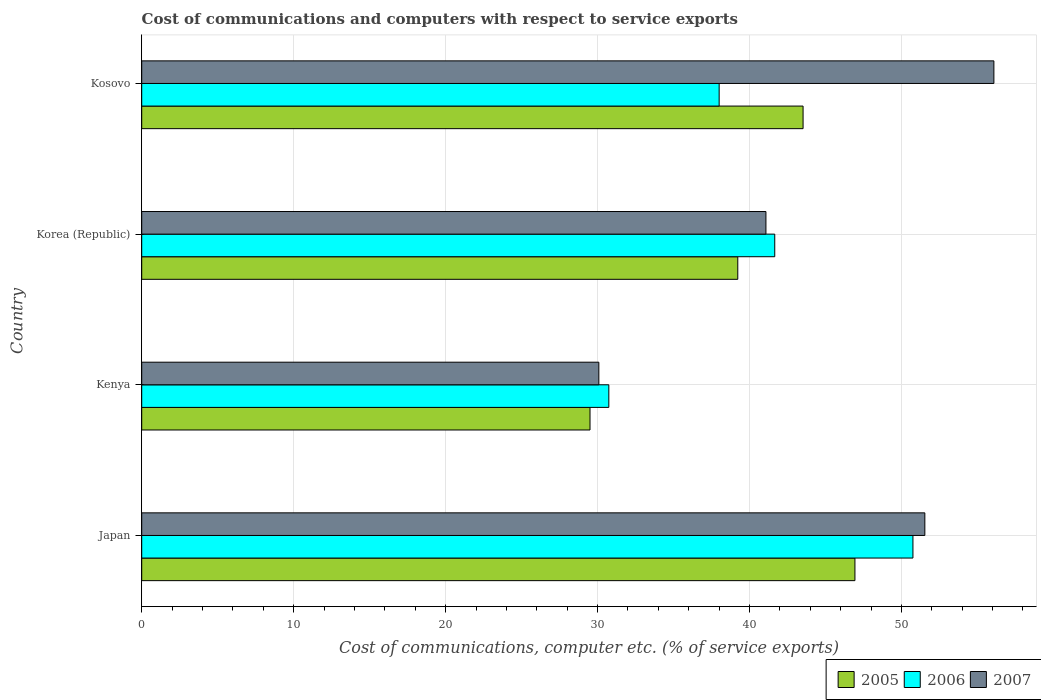How many different coloured bars are there?
Your response must be concise. 3. Are the number of bars per tick equal to the number of legend labels?
Provide a short and direct response. Yes. How many bars are there on the 2nd tick from the bottom?
Make the answer very short. 3. What is the label of the 2nd group of bars from the top?
Your answer should be very brief. Korea (Republic). In how many cases, is the number of bars for a given country not equal to the number of legend labels?
Provide a succinct answer. 0. What is the cost of communications and computers in 2005 in Japan?
Your answer should be compact. 46.94. Across all countries, what is the maximum cost of communications and computers in 2006?
Provide a short and direct response. 50.76. Across all countries, what is the minimum cost of communications and computers in 2005?
Offer a very short reply. 29.5. In which country was the cost of communications and computers in 2007 minimum?
Provide a succinct answer. Kenya. What is the total cost of communications and computers in 2007 in the graph?
Your answer should be very brief. 178.8. What is the difference between the cost of communications and computers in 2007 in Japan and that in Kenya?
Give a very brief answer. 21.46. What is the difference between the cost of communications and computers in 2007 in Kosovo and the cost of communications and computers in 2005 in Kenya?
Keep it short and to the point. 26.58. What is the average cost of communications and computers in 2006 per country?
Make the answer very short. 40.29. What is the difference between the cost of communications and computers in 2006 and cost of communications and computers in 2007 in Korea (Republic)?
Give a very brief answer. 0.58. What is the ratio of the cost of communications and computers in 2005 in Korea (Republic) to that in Kosovo?
Ensure brevity in your answer.  0.9. Is the cost of communications and computers in 2007 in Japan less than that in Kenya?
Make the answer very short. No. Is the difference between the cost of communications and computers in 2006 in Kenya and Korea (Republic) greater than the difference between the cost of communications and computers in 2007 in Kenya and Korea (Republic)?
Offer a terse response. Yes. What is the difference between the highest and the second highest cost of communications and computers in 2007?
Give a very brief answer. 4.54. What is the difference between the highest and the lowest cost of communications and computers in 2007?
Ensure brevity in your answer.  26. What does the 3rd bar from the top in Korea (Republic) represents?
Offer a very short reply. 2005. What does the 1st bar from the bottom in Kosovo represents?
Keep it short and to the point. 2005. Is it the case that in every country, the sum of the cost of communications and computers in 2005 and cost of communications and computers in 2006 is greater than the cost of communications and computers in 2007?
Your answer should be very brief. Yes. How many bars are there?
Provide a short and direct response. 12. Are all the bars in the graph horizontal?
Provide a short and direct response. Yes. What is the difference between two consecutive major ticks on the X-axis?
Give a very brief answer. 10. Are the values on the major ticks of X-axis written in scientific E-notation?
Keep it short and to the point. No. Does the graph contain any zero values?
Offer a terse response. No. Where does the legend appear in the graph?
Provide a short and direct response. Bottom right. How many legend labels are there?
Keep it short and to the point. 3. What is the title of the graph?
Your answer should be compact. Cost of communications and computers with respect to service exports. What is the label or title of the X-axis?
Ensure brevity in your answer.  Cost of communications, computer etc. (% of service exports). What is the label or title of the Y-axis?
Keep it short and to the point. Country. What is the Cost of communications, computer etc. (% of service exports) of 2005 in Japan?
Ensure brevity in your answer.  46.94. What is the Cost of communications, computer etc. (% of service exports) in 2006 in Japan?
Your response must be concise. 50.76. What is the Cost of communications, computer etc. (% of service exports) in 2007 in Japan?
Ensure brevity in your answer.  51.54. What is the Cost of communications, computer etc. (% of service exports) in 2005 in Kenya?
Your answer should be compact. 29.5. What is the Cost of communications, computer etc. (% of service exports) in 2006 in Kenya?
Provide a succinct answer. 30.74. What is the Cost of communications, computer etc. (% of service exports) of 2007 in Kenya?
Give a very brief answer. 30.09. What is the Cost of communications, computer etc. (% of service exports) of 2005 in Korea (Republic)?
Keep it short and to the point. 39.23. What is the Cost of communications, computer etc. (% of service exports) of 2006 in Korea (Republic)?
Provide a succinct answer. 41.66. What is the Cost of communications, computer etc. (% of service exports) in 2007 in Korea (Republic)?
Offer a terse response. 41.08. What is the Cost of communications, computer etc. (% of service exports) of 2005 in Kosovo?
Offer a terse response. 43.53. What is the Cost of communications, computer etc. (% of service exports) of 2006 in Kosovo?
Give a very brief answer. 38. What is the Cost of communications, computer etc. (% of service exports) of 2007 in Kosovo?
Give a very brief answer. 56.09. Across all countries, what is the maximum Cost of communications, computer etc. (% of service exports) in 2005?
Your answer should be very brief. 46.94. Across all countries, what is the maximum Cost of communications, computer etc. (% of service exports) of 2006?
Ensure brevity in your answer.  50.76. Across all countries, what is the maximum Cost of communications, computer etc. (% of service exports) in 2007?
Offer a very short reply. 56.09. Across all countries, what is the minimum Cost of communications, computer etc. (% of service exports) of 2005?
Provide a short and direct response. 29.5. Across all countries, what is the minimum Cost of communications, computer etc. (% of service exports) of 2006?
Ensure brevity in your answer.  30.74. Across all countries, what is the minimum Cost of communications, computer etc. (% of service exports) of 2007?
Provide a short and direct response. 30.09. What is the total Cost of communications, computer etc. (% of service exports) of 2005 in the graph?
Offer a very short reply. 159.2. What is the total Cost of communications, computer etc. (% of service exports) of 2006 in the graph?
Offer a terse response. 161.17. What is the total Cost of communications, computer etc. (% of service exports) of 2007 in the graph?
Offer a very short reply. 178.8. What is the difference between the Cost of communications, computer etc. (% of service exports) in 2005 in Japan and that in Kenya?
Provide a short and direct response. 17.44. What is the difference between the Cost of communications, computer etc. (% of service exports) in 2006 in Japan and that in Kenya?
Keep it short and to the point. 20.01. What is the difference between the Cost of communications, computer etc. (% of service exports) in 2007 in Japan and that in Kenya?
Ensure brevity in your answer.  21.46. What is the difference between the Cost of communications, computer etc. (% of service exports) of 2005 in Japan and that in Korea (Republic)?
Make the answer very short. 7.71. What is the difference between the Cost of communications, computer etc. (% of service exports) in 2006 in Japan and that in Korea (Republic)?
Ensure brevity in your answer.  9.09. What is the difference between the Cost of communications, computer etc. (% of service exports) of 2007 in Japan and that in Korea (Republic)?
Keep it short and to the point. 10.46. What is the difference between the Cost of communications, computer etc. (% of service exports) of 2005 in Japan and that in Kosovo?
Provide a succinct answer. 3.41. What is the difference between the Cost of communications, computer etc. (% of service exports) in 2006 in Japan and that in Kosovo?
Ensure brevity in your answer.  12.75. What is the difference between the Cost of communications, computer etc. (% of service exports) of 2007 in Japan and that in Kosovo?
Keep it short and to the point. -4.54. What is the difference between the Cost of communications, computer etc. (% of service exports) in 2005 in Kenya and that in Korea (Republic)?
Offer a very short reply. -9.72. What is the difference between the Cost of communications, computer etc. (% of service exports) in 2006 in Kenya and that in Korea (Republic)?
Your answer should be compact. -10.92. What is the difference between the Cost of communications, computer etc. (% of service exports) of 2007 in Kenya and that in Korea (Republic)?
Give a very brief answer. -11. What is the difference between the Cost of communications, computer etc. (% of service exports) of 2005 in Kenya and that in Kosovo?
Your answer should be very brief. -14.02. What is the difference between the Cost of communications, computer etc. (% of service exports) in 2006 in Kenya and that in Kosovo?
Your response must be concise. -7.26. What is the difference between the Cost of communications, computer etc. (% of service exports) of 2007 in Kenya and that in Kosovo?
Provide a succinct answer. -26. What is the difference between the Cost of communications, computer etc. (% of service exports) in 2005 in Korea (Republic) and that in Kosovo?
Your answer should be compact. -4.3. What is the difference between the Cost of communications, computer etc. (% of service exports) of 2006 in Korea (Republic) and that in Kosovo?
Your answer should be compact. 3.66. What is the difference between the Cost of communications, computer etc. (% of service exports) of 2007 in Korea (Republic) and that in Kosovo?
Ensure brevity in your answer.  -15. What is the difference between the Cost of communications, computer etc. (% of service exports) in 2005 in Japan and the Cost of communications, computer etc. (% of service exports) in 2006 in Kenya?
Provide a short and direct response. 16.2. What is the difference between the Cost of communications, computer etc. (% of service exports) in 2005 in Japan and the Cost of communications, computer etc. (% of service exports) in 2007 in Kenya?
Your answer should be very brief. 16.85. What is the difference between the Cost of communications, computer etc. (% of service exports) of 2006 in Japan and the Cost of communications, computer etc. (% of service exports) of 2007 in Kenya?
Ensure brevity in your answer.  20.67. What is the difference between the Cost of communications, computer etc. (% of service exports) in 2005 in Japan and the Cost of communications, computer etc. (% of service exports) in 2006 in Korea (Republic)?
Provide a succinct answer. 5.28. What is the difference between the Cost of communications, computer etc. (% of service exports) in 2005 in Japan and the Cost of communications, computer etc. (% of service exports) in 2007 in Korea (Republic)?
Keep it short and to the point. 5.86. What is the difference between the Cost of communications, computer etc. (% of service exports) in 2006 in Japan and the Cost of communications, computer etc. (% of service exports) in 2007 in Korea (Republic)?
Offer a very short reply. 9.67. What is the difference between the Cost of communications, computer etc. (% of service exports) of 2005 in Japan and the Cost of communications, computer etc. (% of service exports) of 2006 in Kosovo?
Ensure brevity in your answer.  8.94. What is the difference between the Cost of communications, computer etc. (% of service exports) of 2005 in Japan and the Cost of communications, computer etc. (% of service exports) of 2007 in Kosovo?
Your response must be concise. -9.14. What is the difference between the Cost of communications, computer etc. (% of service exports) in 2006 in Japan and the Cost of communications, computer etc. (% of service exports) in 2007 in Kosovo?
Your response must be concise. -5.33. What is the difference between the Cost of communications, computer etc. (% of service exports) of 2005 in Kenya and the Cost of communications, computer etc. (% of service exports) of 2006 in Korea (Republic)?
Give a very brief answer. -12.16. What is the difference between the Cost of communications, computer etc. (% of service exports) in 2005 in Kenya and the Cost of communications, computer etc. (% of service exports) in 2007 in Korea (Republic)?
Offer a very short reply. -11.58. What is the difference between the Cost of communications, computer etc. (% of service exports) in 2006 in Kenya and the Cost of communications, computer etc. (% of service exports) in 2007 in Korea (Republic)?
Give a very brief answer. -10.34. What is the difference between the Cost of communications, computer etc. (% of service exports) of 2005 in Kenya and the Cost of communications, computer etc. (% of service exports) of 2006 in Kosovo?
Keep it short and to the point. -8.5. What is the difference between the Cost of communications, computer etc. (% of service exports) in 2005 in Kenya and the Cost of communications, computer etc. (% of service exports) in 2007 in Kosovo?
Keep it short and to the point. -26.58. What is the difference between the Cost of communications, computer etc. (% of service exports) of 2006 in Kenya and the Cost of communications, computer etc. (% of service exports) of 2007 in Kosovo?
Offer a very short reply. -25.34. What is the difference between the Cost of communications, computer etc. (% of service exports) of 2005 in Korea (Republic) and the Cost of communications, computer etc. (% of service exports) of 2006 in Kosovo?
Your answer should be very brief. 1.23. What is the difference between the Cost of communications, computer etc. (% of service exports) of 2005 in Korea (Republic) and the Cost of communications, computer etc. (% of service exports) of 2007 in Kosovo?
Your response must be concise. -16.86. What is the difference between the Cost of communications, computer etc. (% of service exports) of 2006 in Korea (Republic) and the Cost of communications, computer etc. (% of service exports) of 2007 in Kosovo?
Offer a terse response. -14.42. What is the average Cost of communications, computer etc. (% of service exports) of 2005 per country?
Ensure brevity in your answer.  39.8. What is the average Cost of communications, computer etc. (% of service exports) of 2006 per country?
Provide a short and direct response. 40.29. What is the average Cost of communications, computer etc. (% of service exports) of 2007 per country?
Provide a succinct answer. 44.7. What is the difference between the Cost of communications, computer etc. (% of service exports) of 2005 and Cost of communications, computer etc. (% of service exports) of 2006 in Japan?
Offer a terse response. -3.82. What is the difference between the Cost of communications, computer etc. (% of service exports) in 2005 and Cost of communications, computer etc. (% of service exports) in 2007 in Japan?
Offer a terse response. -4.6. What is the difference between the Cost of communications, computer etc. (% of service exports) of 2006 and Cost of communications, computer etc. (% of service exports) of 2007 in Japan?
Your response must be concise. -0.78. What is the difference between the Cost of communications, computer etc. (% of service exports) of 2005 and Cost of communications, computer etc. (% of service exports) of 2006 in Kenya?
Ensure brevity in your answer.  -1.24. What is the difference between the Cost of communications, computer etc. (% of service exports) of 2005 and Cost of communications, computer etc. (% of service exports) of 2007 in Kenya?
Offer a very short reply. -0.58. What is the difference between the Cost of communications, computer etc. (% of service exports) in 2006 and Cost of communications, computer etc. (% of service exports) in 2007 in Kenya?
Ensure brevity in your answer.  0.66. What is the difference between the Cost of communications, computer etc. (% of service exports) of 2005 and Cost of communications, computer etc. (% of service exports) of 2006 in Korea (Republic)?
Provide a short and direct response. -2.43. What is the difference between the Cost of communications, computer etc. (% of service exports) of 2005 and Cost of communications, computer etc. (% of service exports) of 2007 in Korea (Republic)?
Make the answer very short. -1.85. What is the difference between the Cost of communications, computer etc. (% of service exports) of 2006 and Cost of communications, computer etc. (% of service exports) of 2007 in Korea (Republic)?
Provide a short and direct response. 0.58. What is the difference between the Cost of communications, computer etc. (% of service exports) in 2005 and Cost of communications, computer etc. (% of service exports) in 2006 in Kosovo?
Your answer should be compact. 5.52. What is the difference between the Cost of communications, computer etc. (% of service exports) in 2005 and Cost of communications, computer etc. (% of service exports) in 2007 in Kosovo?
Your response must be concise. -12.56. What is the difference between the Cost of communications, computer etc. (% of service exports) of 2006 and Cost of communications, computer etc. (% of service exports) of 2007 in Kosovo?
Make the answer very short. -18.08. What is the ratio of the Cost of communications, computer etc. (% of service exports) of 2005 in Japan to that in Kenya?
Give a very brief answer. 1.59. What is the ratio of the Cost of communications, computer etc. (% of service exports) in 2006 in Japan to that in Kenya?
Keep it short and to the point. 1.65. What is the ratio of the Cost of communications, computer etc. (% of service exports) of 2007 in Japan to that in Kenya?
Your response must be concise. 1.71. What is the ratio of the Cost of communications, computer etc. (% of service exports) in 2005 in Japan to that in Korea (Republic)?
Offer a very short reply. 1.2. What is the ratio of the Cost of communications, computer etc. (% of service exports) of 2006 in Japan to that in Korea (Republic)?
Your answer should be very brief. 1.22. What is the ratio of the Cost of communications, computer etc. (% of service exports) of 2007 in Japan to that in Korea (Republic)?
Your response must be concise. 1.25. What is the ratio of the Cost of communications, computer etc. (% of service exports) in 2005 in Japan to that in Kosovo?
Provide a succinct answer. 1.08. What is the ratio of the Cost of communications, computer etc. (% of service exports) in 2006 in Japan to that in Kosovo?
Your answer should be compact. 1.34. What is the ratio of the Cost of communications, computer etc. (% of service exports) in 2007 in Japan to that in Kosovo?
Give a very brief answer. 0.92. What is the ratio of the Cost of communications, computer etc. (% of service exports) of 2005 in Kenya to that in Korea (Republic)?
Offer a very short reply. 0.75. What is the ratio of the Cost of communications, computer etc. (% of service exports) in 2006 in Kenya to that in Korea (Republic)?
Ensure brevity in your answer.  0.74. What is the ratio of the Cost of communications, computer etc. (% of service exports) in 2007 in Kenya to that in Korea (Republic)?
Your response must be concise. 0.73. What is the ratio of the Cost of communications, computer etc. (% of service exports) in 2005 in Kenya to that in Kosovo?
Offer a terse response. 0.68. What is the ratio of the Cost of communications, computer etc. (% of service exports) in 2006 in Kenya to that in Kosovo?
Make the answer very short. 0.81. What is the ratio of the Cost of communications, computer etc. (% of service exports) in 2007 in Kenya to that in Kosovo?
Your answer should be very brief. 0.54. What is the ratio of the Cost of communications, computer etc. (% of service exports) of 2005 in Korea (Republic) to that in Kosovo?
Offer a terse response. 0.9. What is the ratio of the Cost of communications, computer etc. (% of service exports) of 2006 in Korea (Republic) to that in Kosovo?
Ensure brevity in your answer.  1.1. What is the ratio of the Cost of communications, computer etc. (% of service exports) in 2007 in Korea (Republic) to that in Kosovo?
Ensure brevity in your answer.  0.73. What is the difference between the highest and the second highest Cost of communications, computer etc. (% of service exports) in 2005?
Your answer should be very brief. 3.41. What is the difference between the highest and the second highest Cost of communications, computer etc. (% of service exports) of 2006?
Offer a terse response. 9.09. What is the difference between the highest and the second highest Cost of communications, computer etc. (% of service exports) of 2007?
Provide a succinct answer. 4.54. What is the difference between the highest and the lowest Cost of communications, computer etc. (% of service exports) in 2005?
Make the answer very short. 17.44. What is the difference between the highest and the lowest Cost of communications, computer etc. (% of service exports) of 2006?
Your answer should be compact. 20.01. What is the difference between the highest and the lowest Cost of communications, computer etc. (% of service exports) of 2007?
Your answer should be very brief. 26. 